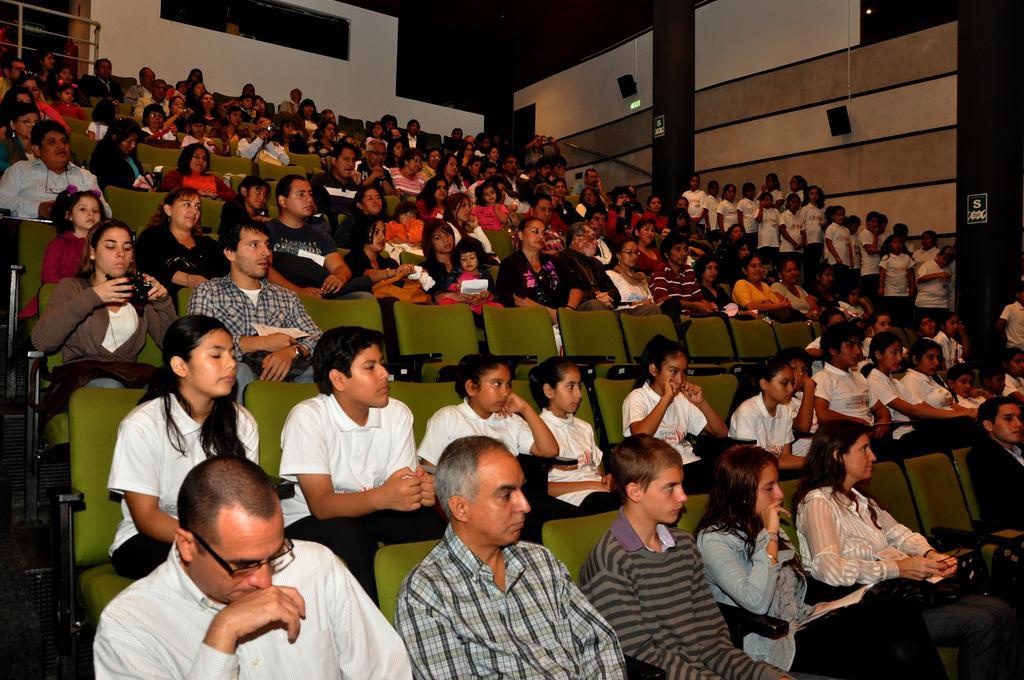Describe this image in one or two sentences. People are sitting on green chairs in an auditorium. People are standing at the right wearing white t shirts. 